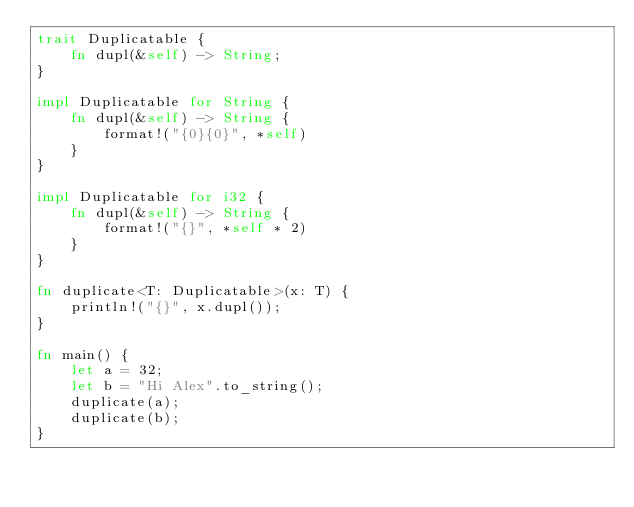<code> <loc_0><loc_0><loc_500><loc_500><_Rust_>trait Duplicatable {
    fn dupl(&self) -> String;
}

impl Duplicatable for String {
    fn dupl(&self) -> String {
        format!("{0}{0}", *self)
    }
}

impl Duplicatable for i32 {
    fn dupl(&self) -> String {
        format!("{}", *self * 2)
    }
}

fn duplicate<T: Duplicatable>(x: T) {
    println!("{}", x.dupl());
}

fn main() {
    let a = 32;
    let b = "Hi Alex".to_string();
    duplicate(a);
    duplicate(b);
}
</code> 